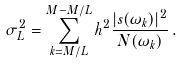<formula> <loc_0><loc_0><loc_500><loc_500>\sigma ^ { 2 } _ { L } = \sum _ { k = M / L } ^ { M - M / L } h ^ { 2 } \frac { | s ( \omega _ { k } ) | ^ { 2 } } { N ( \omega _ { k } ) } \, .</formula> 